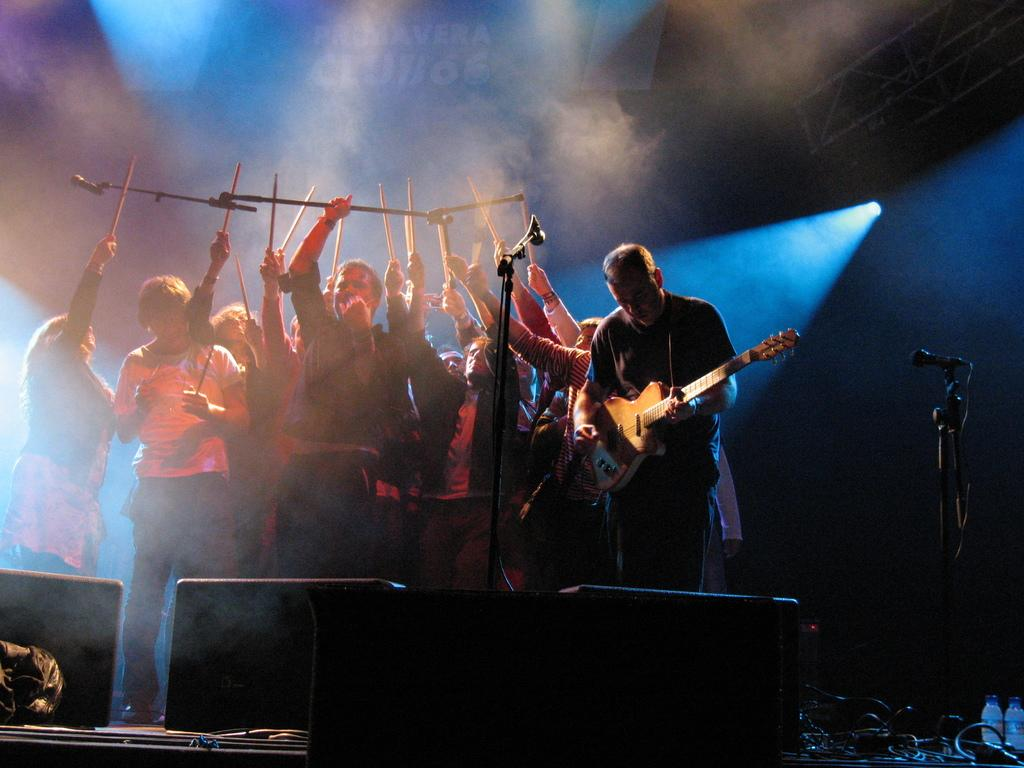How many people are in the image? There are many persons standing in the image. What are the people holding in their hands? The persons are holding sticks. Can you describe the person who is not holding a stick? One person is holding a guitar and playing it. What equipment is visible in the image that is related to music? There are mic stands and speakers in the image. Where is the throne located in the image? There is no throne present in the image. What type of soap is being used by the persons in the image? There is no soap present in the image. 